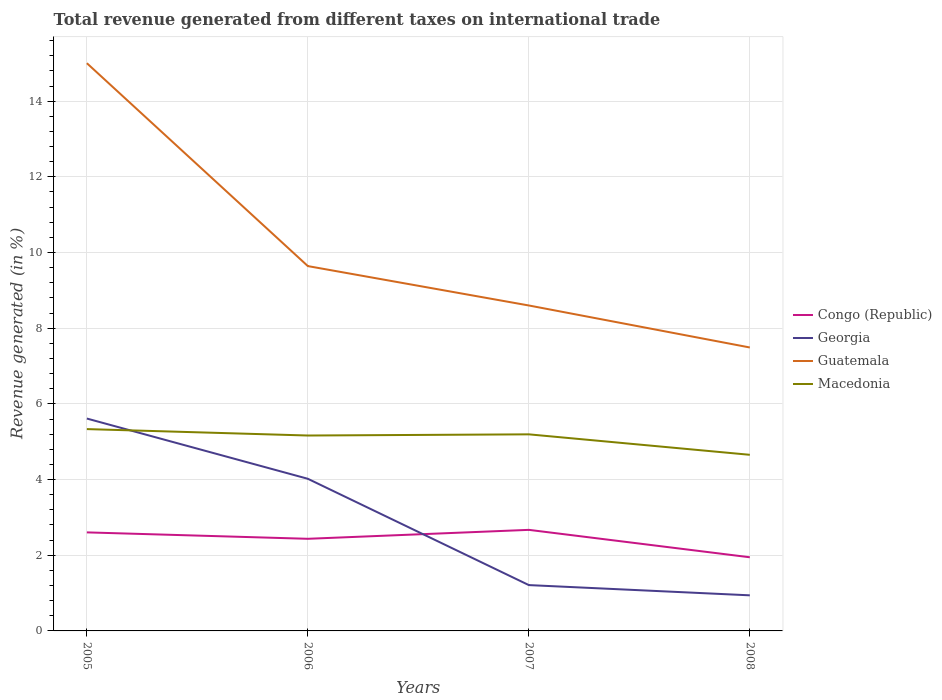How many different coloured lines are there?
Offer a terse response. 4. Across all years, what is the maximum total revenue generated in Guatemala?
Provide a short and direct response. 7.49. What is the total total revenue generated in Georgia in the graph?
Your answer should be compact. 3.08. What is the difference between the highest and the second highest total revenue generated in Congo (Republic)?
Keep it short and to the point. 0.72. Is the total revenue generated in Guatemala strictly greater than the total revenue generated in Congo (Republic) over the years?
Offer a very short reply. No. How many lines are there?
Provide a short and direct response. 4. How many years are there in the graph?
Your answer should be very brief. 4. Does the graph contain any zero values?
Ensure brevity in your answer.  No. What is the title of the graph?
Provide a succinct answer. Total revenue generated from different taxes on international trade. What is the label or title of the Y-axis?
Give a very brief answer. Revenue generated (in %). What is the Revenue generated (in %) of Congo (Republic) in 2005?
Ensure brevity in your answer.  2.6. What is the Revenue generated (in %) of Georgia in 2005?
Provide a succinct answer. 5.61. What is the Revenue generated (in %) in Guatemala in 2005?
Give a very brief answer. 15. What is the Revenue generated (in %) of Macedonia in 2005?
Make the answer very short. 5.33. What is the Revenue generated (in %) in Congo (Republic) in 2006?
Ensure brevity in your answer.  2.43. What is the Revenue generated (in %) in Georgia in 2006?
Make the answer very short. 4.02. What is the Revenue generated (in %) in Guatemala in 2006?
Make the answer very short. 9.64. What is the Revenue generated (in %) of Macedonia in 2006?
Give a very brief answer. 5.16. What is the Revenue generated (in %) of Congo (Republic) in 2007?
Your response must be concise. 2.67. What is the Revenue generated (in %) in Georgia in 2007?
Provide a short and direct response. 1.21. What is the Revenue generated (in %) in Guatemala in 2007?
Your answer should be compact. 8.6. What is the Revenue generated (in %) of Macedonia in 2007?
Ensure brevity in your answer.  5.19. What is the Revenue generated (in %) of Congo (Republic) in 2008?
Offer a very short reply. 1.95. What is the Revenue generated (in %) in Georgia in 2008?
Ensure brevity in your answer.  0.94. What is the Revenue generated (in %) of Guatemala in 2008?
Offer a terse response. 7.49. What is the Revenue generated (in %) in Macedonia in 2008?
Offer a very short reply. 4.65. Across all years, what is the maximum Revenue generated (in %) of Congo (Republic)?
Provide a succinct answer. 2.67. Across all years, what is the maximum Revenue generated (in %) of Georgia?
Offer a very short reply. 5.61. Across all years, what is the maximum Revenue generated (in %) of Guatemala?
Your answer should be very brief. 15. Across all years, what is the maximum Revenue generated (in %) in Macedonia?
Provide a short and direct response. 5.33. Across all years, what is the minimum Revenue generated (in %) in Congo (Republic)?
Offer a very short reply. 1.95. Across all years, what is the minimum Revenue generated (in %) in Georgia?
Ensure brevity in your answer.  0.94. Across all years, what is the minimum Revenue generated (in %) in Guatemala?
Offer a very short reply. 7.49. Across all years, what is the minimum Revenue generated (in %) of Macedonia?
Provide a short and direct response. 4.65. What is the total Revenue generated (in %) of Congo (Republic) in the graph?
Ensure brevity in your answer.  9.66. What is the total Revenue generated (in %) of Georgia in the graph?
Your response must be concise. 11.78. What is the total Revenue generated (in %) of Guatemala in the graph?
Your answer should be very brief. 40.73. What is the total Revenue generated (in %) of Macedonia in the graph?
Your answer should be very brief. 20.35. What is the difference between the Revenue generated (in %) of Congo (Republic) in 2005 and that in 2006?
Offer a very short reply. 0.17. What is the difference between the Revenue generated (in %) in Georgia in 2005 and that in 2006?
Ensure brevity in your answer.  1.59. What is the difference between the Revenue generated (in %) in Guatemala in 2005 and that in 2006?
Give a very brief answer. 5.36. What is the difference between the Revenue generated (in %) in Macedonia in 2005 and that in 2006?
Make the answer very short. 0.17. What is the difference between the Revenue generated (in %) in Congo (Republic) in 2005 and that in 2007?
Provide a succinct answer. -0.07. What is the difference between the Revenue generated (in %) in Georgia in 2005 and that in 2007?
Keep it short and to the point. 4.4. What is the difference between the Revenue generated (in %) in Guatemala in 2005 and that in 2007?
Your answer should be very brief. 6.4. What is the difference between the Revenue generated (in %) in Macedonia in 2005 and that in 2007?
Keep it short and to the point. 0.14. What is the difference between the Revenue generated (in %) in Congo (Republic) in 2005 and that in 2008?
Keep it short and to the point. 0.66. What is the difference between the Revenue generated (in %) of Georgia in 2005 and that in 2008?
Ensure brevity in your answer.  4.67. What is the difference between the Revenue generated (in %) of Guatemala in 2005 and that in 2008?
Ensure brevity in your answer.  7.51. What is the difference between the Revenue generated (in %) in Macedonia in 2005 and that in 2008?
Your response must be concise. 0.68. What is the difference between the Revenue generated (in %) of Congo (Republic) in 2006 and that in 2007?
Your answer should be very brief. -0.24. What is the difference between the Revenue generated (in %) in Georgia in 2006 and that in 2007?
Your answer should be compact. 2.81. What is the difference between the Revenue generated (in %) of Guatemala in 2006 and that in 2007?
Offer a terse response. 1.04. What is the difference between the Revenue generated (in %) in Macedonia in 2006 and that in 2007?
Make the answer very short. -0.03. What is the difference between the Revenue generated (in %) of Congo (Republic) in 2006 and that in 2008?
Provide a succinct answer. 0.49. What is the difference between the Revenue generated (in %) in Georgia in 2006 and that in 2008?
Provide a short and direct response. 3.08. What is the difference between the Revenue generated (in %) of Guatemala in 2006 and that in 2008?
Offer a terse response. 2.15. What is the difference between the Revenue generated (in %) in Macedonia in 2006 and that in 2008?
Your response must be concise. 0.51. What is the difference between the Revenue generated (in %) of Congo (Republic) in 2007 and that in 2008?
Keep it short and to the point. 0.72. What is the difference between the Revenue generated (in %) in Georgia in 2007 and that in 2008?
Offer a very short reply. 0.27. What is the difference between the Revenue generated (in %) of Guatemala in 2007 and that in 2008?
Offer a terse response. 1.11. What is the difference between the Revenue generated (in %) in Macedonia in 2007 and that in 2008?
Keep it short and to the point. 0.54. What is the difference between the Revenue generated (in %) of Congo (Republic) in 2005 and the Revenue generated (in %) of Georgia in 2006?
Keep it short and to the point. -1.42. What is the difference between the Revenue generated (in %) in Congo (Republic) in 2005 and the Revenue generated (in %) in Guatemala in 2006?
Your response must be concise. -7.04. What is the difference between the Revenue generated (in %) of Congo (Republic) in 2005 and the Revenue generated (in %) of Macedonia in 2006?
Your answer should be compact. -2.56. What is the difference between the Revenue generated (in %) in Georgia in 2005 and the Revenue generated (in %) in Guatemala in 2006?
Provide a succinct answer. -4.03. What is the difference between the Revenue generated (in %) in Georgia in 2005 and the Revenue generated (in %) in Macedonia in 2006?
Keep it short and to the point. 0.45. What is the difference between the Revenue generated (in %) of Guatemala in 2005 and the Revenue generated (in %) of Macedonia in 2006?
Offer a terse response. 9.84. What is the difference between the Revenue generated (in %) of Congo (Republic) in 2005 and the Revenue generated (in %) of Georgia in 2007?
Give a very brief answer. 1.39. What is the difference between the Revenue generated (in %) of Congo (Republic) in 2005 and the Revenue generated (in %) of Guatemala in 2007?
Provide a short and direct response. -6. What is the difference between the Revenue generated (in %) in Congo (Republic) in 2005 and the Revenue generated (in %) in Macedonia in 2007?
Your response must be concise. -2.59. What is the difference between the Revenue generated (in %) of Georgia in 2005 and the Revenue generated (in %) of Guatemala in 2007?
Offer a very short reply. -2.99. What is the difference between the Revenue generated (in %) of Georgia in 2005 and the Revenue generated (in %) of Macedonia in 2007?
Ensure brevity in your answer.  0.42. What is the difference between the Revenue generated (in %) in Guatemala in 2005 and the Revenue generated (in %) in Macedonia in 2007?
Ensure brevity in your answer.  9.81. What is the difference between the Revenue generated (in %) of Congo (Republic) in 2005 and the Revenue generated (in %) of Georgia in 2008?
Provide a succinct answer. 1.66. What is the difference between the Revenue generated (in %) of Congo (Republic) in 2005 and the Revenue generated (in %) of Guatemala in 2008?
Make the answer very short. -4.89. What is the difference between the Revenue generated (in %) in Congo (Republic) in 2005 and the Revenue generated (in %) in Macedonia in 2008?
Provide a short and direct response. -2.05. What is the difference between the Revenue generated (in %) of Georgia in 2005 and the Revenue generated (in %) of Guatemala in 2008?
Your answer should be compact. -1.88. What is the difference between the Revenue generated (in %) of Georgia in 2005 and the Revenue generated (in %) of Macedonia in 2008?
Provide a short and direct response. 0.96. What is the difference between the Revenue generated (in %) in Guatemala in 2005 and the Revenue generated (in %) in Macedonia in 2008?
Your response must be concise. 10.35. What is the difference between the Revenue generated (in %) in Congo (Republic) in 2006 and the Revenue generated (in %) in Georgia in 2007?
Offer a very short reply. 1.22. What is the difference between the Revenue generated (in %) in Congo (Republic) in 2006 and the Revenue generated (in %) in Guatemala in 2007?
Provide a succinct answer. -6.17. What is the difference between the Revenue generated (in %) in Congo (Republic) in 2006 and the Revenue generated (in %) in Macedonia in 2007?
Your response must be concise. -2.76. What is the difference between the Revenue generated (in %) of Georgia in 2006 and the Revenue generated (in %) of Guatemala in 2007?
Make the answer very short. -4.58. What is the difference between the Revenue generated (in %) of Georgia in 2006 and the Revenue generated (in %) of Macedonia in 2007?
Ensure brevity in your answer.  -1.17. What is the difference between the Revenue generated (in %) of Guatemala in 2006 and the Revenue generated (in %) of Macedonia in 2007?
Your response must be concise. 4.45. What is the difference between the Revenue generated (in %) in Congo (Republic) in 2006 and the Revenue generated (in %) in Georgia in 2008?
Offer a terse response. 1.49. What is the difference between the Revenue generated (in %) in Congo (Republic) in 2006 and the Revenue generated (in %) in Guatemala in 2008?
Make the answer very short. -5.06. What is the difference between the Revenue generated (in %) of Congo (Republic) in 2006 and the Revenue generated (in %) of Macedonia in 2008?
Offer a very short reply. -2.22. What is the difference between the Revenue generated (in %) in Georgia in 2006 and the Revenue generated (in %) in Guatemala in 2008?
Provide a short and direct response. -3.47. What is the difference between the Revenue generated (in %) of Georgia in 2006 and the Revenue generated (in %) of Macedonia in 2008?
Provide a succinct answer. -0.63. What is the difference between the Revenue generated (in %) in Guatemala in 2006 and the Revenue generated (in %) in Macedonia in 2008?
Make the answer very short. 4.99. What is the difference between the Revenue generated (in %) in Congo (Republic) in 2007 and the Revenue generated (in %) in Georgia in 2008?
Provide a short and direct response. 1.73. What is the difference between the Revenue generated (in %) of Congo (Republic) in 2007 and the Revenue generated (in %) of Guatemala in 2008?
Give a very brief answer. -4.82. What is the difference between the Revenue generated (in %) in Congo (Republic) in 2007 and the Revenue generated (in %) in Macedonia in 2008?
Ensure brevity in your answer.  -1.98. What is the difference between the Revenue generated (in %) in Georgia in 2007 and the Revenue generated (in %) in Guatemala in 2008?
Your answer should be very brief. -6.28. What is the difference between the Revenue generated (in %) of Georgia in 2007 and the Revenue generated (in %) of Macedonia in 2008?
Provide a short and direct response. -3.44. What is the difference between the Revenue generated (in %) of Guatemala in 2007 and the Revenue generated (in %) of Macedonia in 2008?
Give a very brief answer. 3.95. What is the average Revenue generated (in %) in Congo (Republic) per year?
Your answer should be compact. 2.41. What is the average Revenue generated (in %) of Georgia per year?
Keep it short and to the point. 2.95. What is the average Revenue generated (in %) in Guatemala per year?
Offer a terse response. 10.18. What is the average Revenue generated (in %) in Macedonia per year?
Your response must be concise. 5.09. In the year 2005, what is the difference between the Revenue generated (in %) in Congo (Republic) and Revenue generated (in %) in Georgia?
Offer a terse response. -3.01. In the year 2005, what is the difference between the Revenue generated (in %) in Congo (Republic) and Revenue generated (in %) in Guatemala?
Provide a succinct answer. -12.4. In the year 2005, what is the difference between the Revenue generated (in %) in Congo (Republic) and Revenue generated (in %) in Macedonia?
Offer a terse response. -2.73. In the year 2005, what is the difference between the Revenue generated (in %) in Georgia and Revenue generated (in %) in Guatemala?
Give a very brief answer. -9.39. In the year 2005, what is the difference between the Revenue generated (in %) in Georgia and Revenue generated (in %) in Macedonia?
Your response must be concise. 0.28. In the year 2005, what is the difference between the Revenue generated (in %) of Guatemala and Revenue generated (in %) of Macedonia?
Your response must be concise. 9.67. In the year 2006, what is the difference between the Revenue generated (in %) of Congo (Republic) and Revenue generated (in %) of Georgia?
Offer a very short reply. -1.59. In the year 2006, what is the difference between the Revenue generated (in %) of Congo (Republic) and Revenue generated (in %) of Guatemala?
Provide a short and direct response. -7.21. In the year 2006, what is the difference between the Revenue generated (in %) of Congo (Republic) and Revenue generated (in %) of Macedonia?
Offer a very short reply. -2.73. In the year 2006, what is the difference between the Revenue generated (in %) of Georgia and Revenue generated (in %) of Guatemala?
Provide a short and direct response. -5.62. In the year 2006, what is the difference between the Revenue generated (in %) in Georgia and Revenue generated (in %) in Macedonia?
Your answer should be very brief. -1.14. In the year 2006, what is the difference between the Revenue generated (in %) in Guatemala and Revenue generated (in %) in Macedonia?
Your answer should be very brief. 4.48. In the year 2007, what is the difference between the Revenue generated (in %) in Congo (Republic) and Revenue generated (in %) in Georgia?
Your answer should be compact. 1.46. In the year 2007, what is the difference between the Revenue generated (in %) in Congo (Republic) and Revenue generated (in %) in Guatemala?
Your answer should be compact. -5.93. In the year 2007, what is the difference between the Revenue generated (in %) of Congo (Republic) and Revenue generated (in %) of Macedonia?
Your answer should be very brief. -2.52. In the year 2007, what is the difference between the Revenue generated (in %) of Georgia and Revenue generated (in %) of Guatemala?
Ensure brevity in your answer.  -7.39. In the year 2007, what is the difference between the Revenue generated (in %) in Georgia and Revenue generated (in %) in Macedonia?
Offer a terse response. -3.98. In the year 2007, what is the difference between the Revenue generated (in %) in Guatemala and Revenue generated (in %) in Macedonia?
Offer a very short reply. 3.41. In the year 2008, what is the difference between the Revenue generated (in %) of Congo (Republic) and Revenue generated (in %) of Guatemala?
Keep it short and to the point. -5.54. In the year 2008, what is the difference between the Revenue generated (in %) of Congo (Republic) and Revenue generated (in %) of Macedonia?
Provide a succinct answer. -2.71. In the year 2008, what is the difference between the Revenue generated (in %) in Georgia and Revenue generated (in %) in Guatemala?
Your response must be concise. -6.55. In the year 2008, what is the difference between the Revenue generated (in %) in Georgia and Revenue generated (in %) in Macedonia?
Your answer should be very brief. -3.71. In the year 2008, what is the difference between the Revenue generated (in %) in Guatemala and Revenue generated (in %) in Macedonia?
Offer a very short reply. 2.84. What is the ratio of the Revenue generated (in %) in Congo (Republic) in 2005 to that in 2006?
Offer a very short reply. 1.07. What is the ratio of the Revenue generated (in %) in Georgia in 2005 to that in 2006?
Your answer should be very brief. 1.4. What is the ratio of the Revenue generated (in %) of Guatemala in 2005 to that in 2006?
Your answer should be compact. 1.56. What is the ratio of the Revenue generated (in %) in Macedonia in 2005 to that in 2006?
Your answer should be very brief. 1.03. What is the ratio of the Revenue generated (in %) in Congo (Republic) in 2005 to that in 2007?
Your response must be concise. 0.97. What is the ratio of the Revenue generated (in %) of Georgia in 2005 to that in 2007?
Your answer should be compact. 4.63. What is the ratio of the Revenue generated (in %) in Guatemala in 2005 to that in 2007?
Make the answer very short. 1.74. What is the ratio of the Revenue generated (in %) in Macedonia in 2005 to that in 2007?
Your answer should be compact. 1.03. What is the ratio of the Revenue generated (in %) of Congo (Republic) in 2005 to that in 2008?
Your answer should be very brief. 1.34. What is the ratio of the Revenue generated (in %) of Georgia in 2005 to that in 2008?
Offer a terse response. 5.97. What is the ratio of the Revenue generated (in %) of Guatemala in 2005 to that in 2008?
Provide a short and direct response. 2. What is the ratio of the Revenue generated (in %) in Macedonia in 2005 to that in 2008?
Make the answer very short. 1.15. What is the ratio of the Revenue generated (in %) of Congo (Republic) in 2006 to that in 2007?
Make the answer very short. 0.91. What is the ratio of the Revenue generated (in %) in Georgia in 2006 to that in 2007?
Your answer should be compact. 3.32. What is the ratio of the Revenue generated (in %) of Guatemala in 2006 to that in 2007?
Offer a very short reply. 1.12. What is the ratio of the Revenue generated (in %) in Congo (Republic) in 2006 to that in 2008?
Give a very brief answer. 1.25. What is the ratio of the Revenue generated (in %) in Georgia in 2006 to that in 2008?
Ensure brevity in your answer.  4.27. What is the ratio of the Revenue generated (in %) in Guatemala in 2006 to that in 2008?
Offer a terse response. 1.29. What is the ratio of the Revenue generated (in %) in Macedonia in 2006 to that in 2008?
Provide a succinct answer. 1.11. What is the ratio of the Revenue generated (in %) of Congo (Republic) in 2007 to that in 2008?
Ensure brevity in your answer.  1.37. What is the ratio of the Revenue generated (in %) in Georgia in 2007 to that in 2008?
Provide a short and direct response. 1.29. What is the ratio of the Revenue generated (in %) of Guatemala in 2007 to that in 2008?
Offer a terse response. 1.15. What is the ratio of the Revenue generated (in %) of Macedonia in 2007 to that in 2008?
Offer a very short reply. 1.12. What is the difference between the highest and the second highest Revenue generated (in %) in Congo (Republic)?
Make the answer very short. 0.07. What is the difference between the highest and the second highest Revenue generated (in %) in Georgia?
Your answer should be compact. 1.59. What is the difference between the highest and the second highest Revenue generated (in %) of Guatemala?
Give a very brief answer. 5.36. What is the difference between the highest and the second highest Revenue generated (in %) of Macedonia?
Provide a short and direct response. 0.14. What is the difference between the highest and the lowest Revenue generated (in %) in Congo (Republic)?
Ensure brevity in your answer.  0.72. What is the difference between the highest and the lowest Revenue generated (in %) in Georgia?
Offer a terse response. 4.67. What is the difference between the highest and the lowest Revenue generated (in %) in Guatemala?
Your answer should be very brief. 7.51. What is the difference between the highest and the lowest Revenue generated (in %) in Macedonia?
Offer a very short reply. 0.68. 